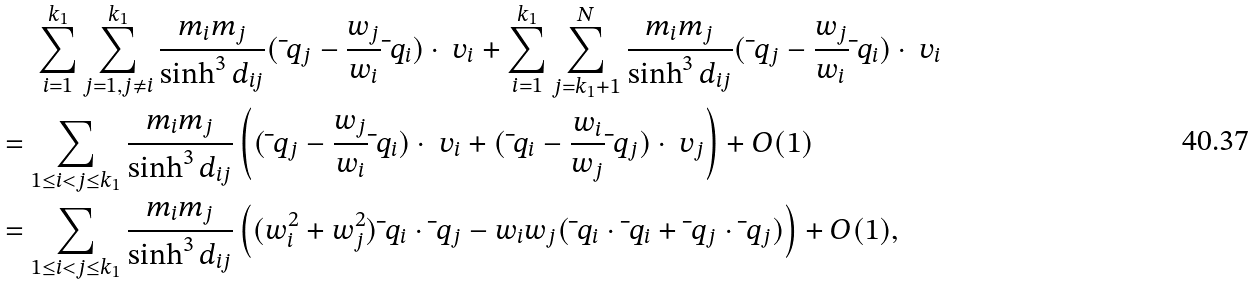Convert formula to latex. <formula><loc_0><loc_0><loc_500><loc_500>& \quad \ \sum _ { i = 1 } ^ { k _ { 1 } } \sum _ { j = 1 , j \ne i } ^ { k _ { 1 } } \frac { m _ { i } m _ { j } } { \sinh ^ { 3 } d _ { i j } } ( \bar { \ } q _ { j } - \frac { w _ { j } } { w _ { i } } \bar { \ } q _ { i } ) \cdot \ v _ { i } + \sum _ { i = 1 } ^ { k _ { 1 } } \sum _ { j = k _ { 1 } + 1 } ^ { N } \frac { m _ { i } m _ { j } } { \sinh ^ { 3 } d _ { i j } } ( \bar { \ } q _ { j } - \frac { w _ { j } } { w _ { i } } \bar { \ } q _ { i } ) \cdot \ v _ { i } \\ & = \sum _ { 1 \leq i < j \leq k _ { 1 } } \frac { m _ { i } m _ { j } } { \sinh ^ { 3 } d _ { i j } } \left ( ( \bar { \ } q _ { j } - \frac { w _ { j } } { w _ { i } } \bar { \ } q _ { i } ) \cdot \ v _ { i } + ( \bar { \ } q _ { i } - \frac { w _ { i } } { w _ { j } } \bar { \ } q _ { j } ) \cdot \ v _ { j } \right ) + O ( 1 ) \\ & = \sum _ { 1 \leq i < j \leq k _ { 1 } } \frac { m _ { i } m _ { j } } { \sinh ^ { 3 } d _ { i j } } \left ( ( w _ { i } ^ { 2 } + w _ { j } ^ { 2 } ) \bar { \ } q _ { i } \cdot \bar { \ } q _ { j } - w _ { i } w _ { j } ( \bar { \ } q _ { i } \cdot \bar { \ } q _ { i } + \bar { \ } q _ { j } \cdot \bar { \ } q _ { j } ) \right ) + O ( 1 ) , \\</formula> 